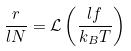Convert formula to latex. <formula><loc_0><loc_0><loc_500><loc_500>\frac { r } { l N } = \mathcal { L } \left ( \frac { l f } { k _ { B } T } \right )</formula> 